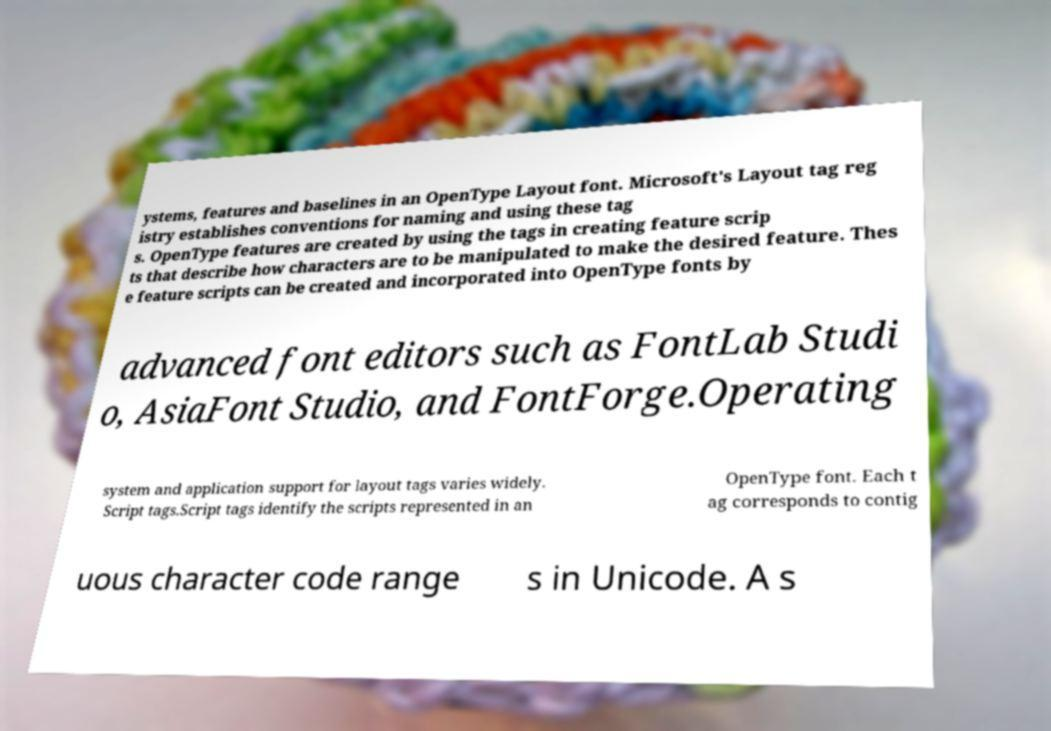Please identify and transcribe the text found in this image. ystems, features and baselines in an OpenType Layout font. Microsoft's Layout tag reg istry establishes conventions for naming and using these tag s. OpenType features are created by using the tags in creating feature scrip ts that describe how characters are to be manipulated to make the desired feature. Thes e feature scripts can be created and incorporated into OpenType fonts by advanced font editors such as FontLab Studi o, AsiaFont Studio, and FontForge.Operating system and application support for layout tags varies widely. Script tags.Script tags identify the scripts represented in an OpenType font. Each t ag corresponds to contig uous character code range s in Unicode. A s 